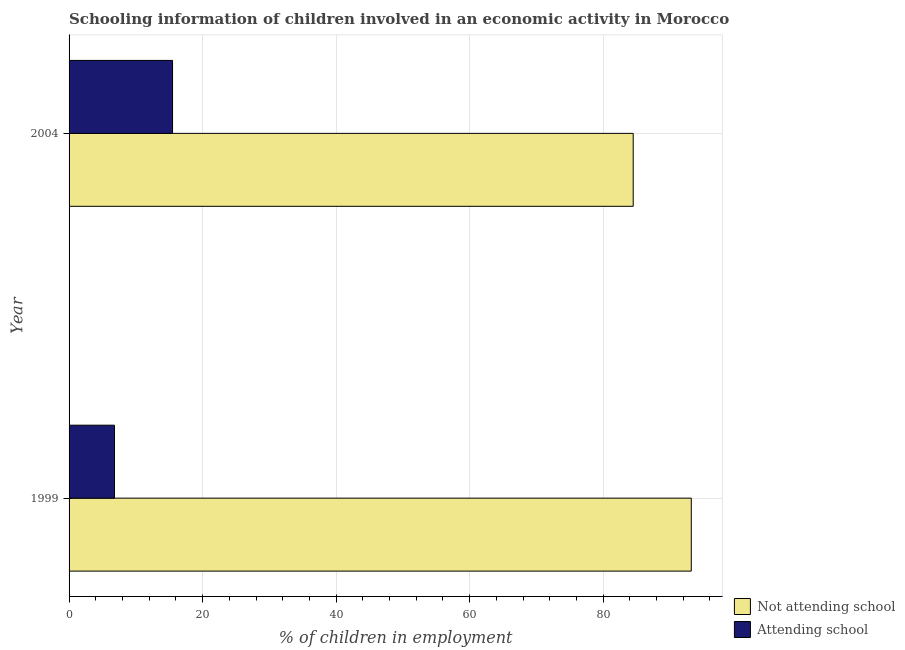How many different coloured bars are there?
Offer a terse response. 2. How many groups of bars are there?
Give a very brief answer. 2. Are the number of bars per tick equal to the number of legend labels?
Provide a short and direct response. Yes. How many bars are there on the 2nd tick from the bottom?
Provide a short and direct response. 2. What is the label of the 2nd group of bars from the top?
Provide a succinct answer. 1999. What is the percentage of employed children who are not attending school in 2004?
Ensure brevity in your answer.  84.5. Across all years, what is the maximum percentage of employed children who are attending school?
Your response must be concise. 15.5. Across all years, what is the minimum percentage of employed children who are attending school?
Ensure brevity in your answer.  6.8. What is the total percentage of employed children who are attending school in the graph?
Provide a succinct answer. 22.3. What is the difference between the percentage of employed children who are not attending school in 1999 and that in 2004?
Make the answer very short. 8.7. What is the difference between the percentage of employed children who are not attending school in 1999 and the percentage of employed children who are attending school in 2004?
Offer a very short reply. 77.7. What is the average percentage of employed children who are not attending school per year?
Offer a terse response. 88.85. In the year 1999, what is the difference between the percentage of employed children who are not attending school and percentage of employed children who are attending school?
Offer a very short reply. 86.4. What is the ratio of the percentage of employed children who are attending school in 1999 to that in 2004?
Ensure brevity in your answer.  0.44. Is the percentage of employed children who are not attending school in 1999 less than that in 2004?
Offer a terse response. No. In how many years, is the percentage of employed children who are attending school greater than the average percentage of employed children who are attending school taken over all years?
Keep it short and to the point. 1. What does the 1st bar from the top in 1999 represents?
Give a very brief answer. Attending school. What does the 1st bar from the bottom in 2004 represents?
Give a very brief answer. Not attending school. How many years are there in the graph?
Keep it short and to the point. 2. Are the values on the major ticks of X-axis written in scientific E-notation?
Your answer should be very brief. No. Does the graph contain grids?
Your answer should be compact. Yes. How many legend labels are there?
Your answer should be very brief. 2. How are the legend labels stacked?
Your answer should be very brief. Vertical. What is the title of the graph?
Your response must be concise. Schooling information of children involved in an economic activity in Morocco. Does "Travel Items" appear as one of the legend labels in the graph?
Your answer should be compact. No. What is the label or title of the X-axis?
Your answer should be compact. % of children in employment. What is the label or title of the Y-axis?
Provide a succinct answer. Year. What is the % of children in employment in Not attending school in 1999?
Offer a very short reply. 93.2. What is the % of children in employment of Attending school in 1999?
Provide a short and direct response. 6.8. What is the % of children in employment in Not attending school in 2004?
Keep it short and to the point. 84.5. Across all years, what is the maximum % of children in employment of Not attending school?
Offer a terse response. 93.2. Across all years, what is the minimum % of children in employment of Not attending school?
Make the answer very short. 84.5. What is the total % of children in employment in Not attending school in the graph?
Offer a terse response. 177.7. What is the total % of children in employment in Attending school in the graph?
Provide a succinct answer. 22.3. What is the difference between the % of children in employment of Not attending school in 1999 and that in 2004?
Your response must be concise. 8.7. What is the difference between the % of children in employment in Not attending school in 1999 and the % of children in employment in Attending school in 2004?
Make the answer very short. 77.7. What is the average % of children in employment of Not attending school per year?
Give a very brief answer. 88.85. What is the average % of children in employment of Attending school per year?
Give a very brief answer. 11.15. In the year 1999, what is the difference between the % of children in employment of Not attending school and % of children in employment of Attending school?
Keep it short and to the point. 86.4. In the year 2004, what is the difference between the % of children in employment in Not attending school and % of children in employment in Attending school?
Provide a short and direct response. 69. What is the ratio of the % of children in employment in Not attending school in 1999 to that in 2004?
Your answer should be very brief. 1.1. What is the ratio of the % of children in employment in Attending school in 1999 to that in 2004?
Offer a terse response. 0.44. What is the difference between the highest and the second highest % of children in employment in Not attending school?
Offer a very short reply. 8.7. What is the difference between the highest and the lowest % of children in employment in Not attending school?
Keep it short and to the point. 8.7. What is the difference between the highest and the lowest % of children in employment of Attending school?
Offer a very short reply. 8.7. 